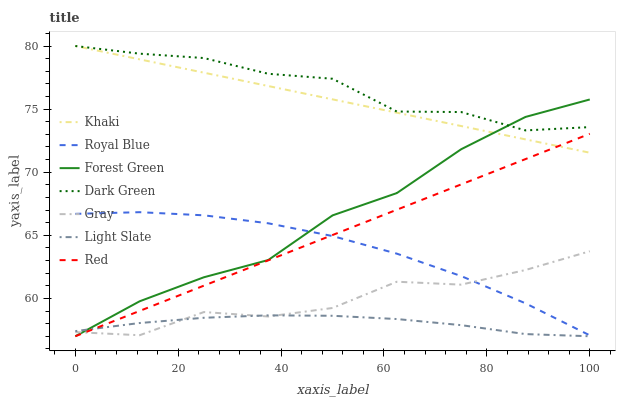Does Light Slate have the minimum area under the curve?
Answer yes or no. Yes. Does Dark Green have the maximum area under the curve?
Answer yes or no. Yes. Does Khaki have the minimum area under the curve?
Answer yes or no. No. Does Khaki have the maximum area under the curve?
Answer yes or no. No. Is Red the smoothest?
Answer yes or no. Yes. Is Gray the roughest?
Answer yes or no. Yes. Is Khaki the smoothest?
Answer yes or no. No. Is Khaki the roughest?
Answer yes or no. No. Does Light Slate have the lowest value?
Answer yes or no. Yes. Does Khaki have the lowest value?
Answer yes or no. No. Does Dark Green have the highest value?
Answer yes or no. Yes. Does Light Slate have the highest value?
Answer yes or no. No. Is Red less than Dark Green?
Answer yes or no. Yes. Is Royal Blue greater than Light Slate?
Answer yes or no. Yes. Does Dark Green intersect Khaki?
Answer yes or no. Yes. Is Dark Green less than Khaki?
Answer yes or no. No. Is Dark Green greater than Khaki?
Answer yes or no. No. Does Red intersect Dark Green?
Answer yes or no. No. 